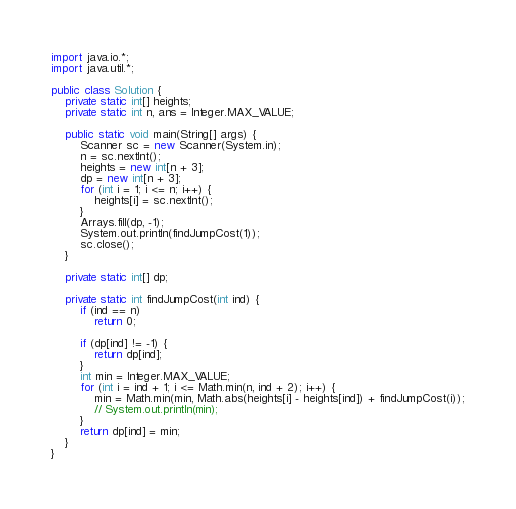Convert code to text. <code><loc_0><loc_0><loc_500><loc_500><_Java_>
import java.io.*;
import java.util.*;

public class Solution {
    private static int[] heights;
    private static int n, ans = Integer.MAX_VALUE;

    public static void main(String[] args) {
        Scanner sc = new Scanner(System.in);
        n = sc.nextInt();
        heights = new int[n + 3];
        dp = new int[n + 3];
        for (int i = 1; i <= n; i++) {
            heights[i] = sc.nextInt();
        }
        Arrays.fill(dp, -1);
        System.out.println(findJumpCost(1));
        sc.close();
    }

    private static int[] dp;

    private static int findJumpCost(int ind) {
        if (ind == n)
            return 0;

        if (dp[ind] != -1) {
            return dp[ind];
        }
        int min = Integer.MAX_VALUE;
        for (int i = ind + 1; i <= Math.min(n, ind + 2); i++) {
            min = Math.min(min, Math.abs(heights[i] - heights[ind]) + findJumpCost(i));
            // System.out.println(min);
        }
        return dp[ind] = min;
    }
}</code> 